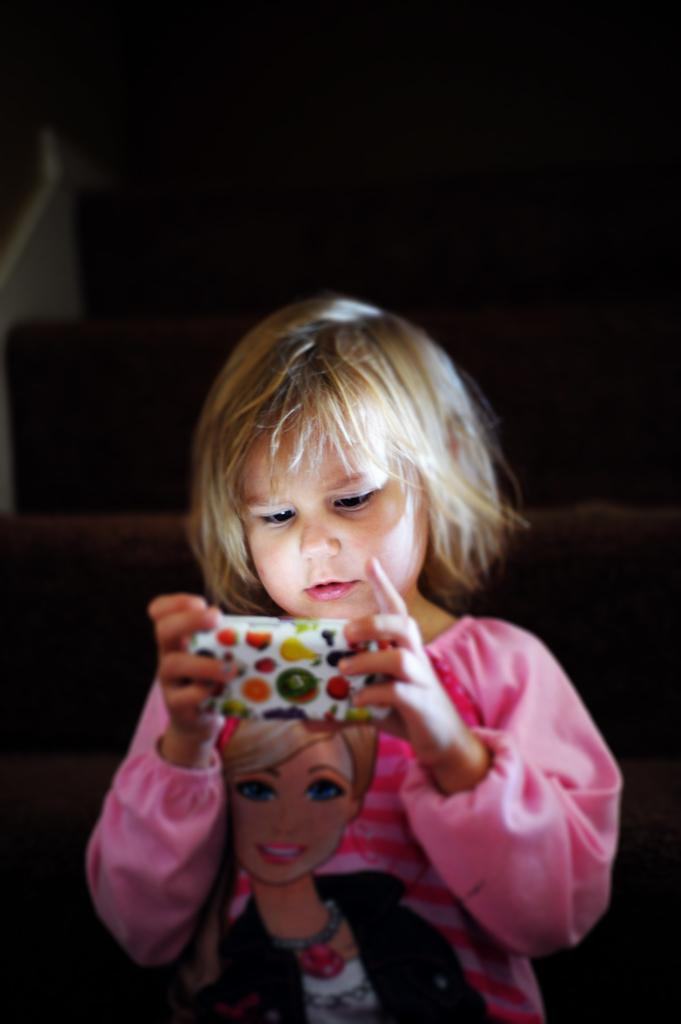Who is the main subject in the image? There is a girl in the image. What is the girl holding in the image? The girl is holding a mobile. What can be observed about the background of the image? The background of the image is dark. What type of yam is the girl holding in the image? There is no yam present in the image; the girl is holding a mobile. Is there a glove visible on the girl's hand in the image? There is no glove visible on the girl's hand in the image. 